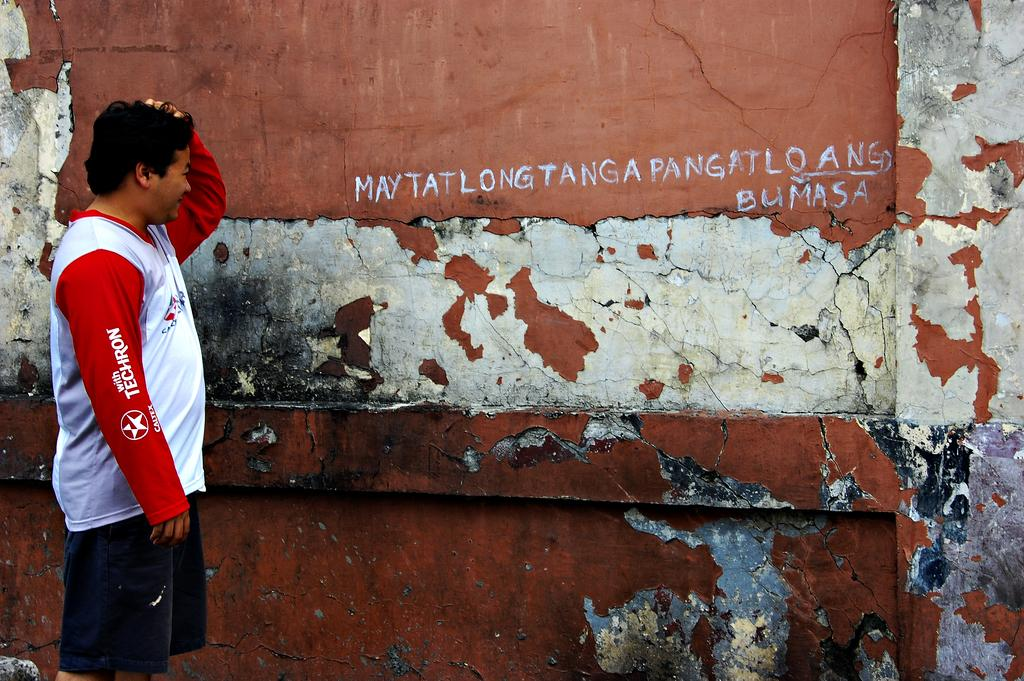Provide a one-sentence caption for the provided image. Young man wearing the Techron shirt reads the wall. 